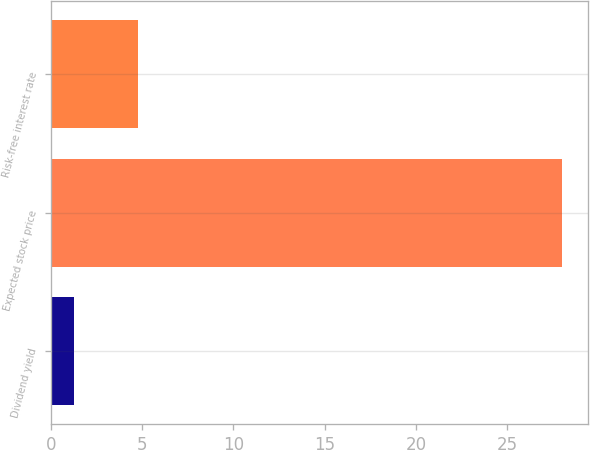Convert chart to OTSL. <chart><loc_0><loc_0><loc_500><loc_500><bar_chart><fcel>Dividend yield<fcel>Expected stock price<fcel>Risk-free interest rate<nl><fcel>1.3<fcel>28<fcel>4.8<nl></chart> 